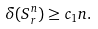Convert formula to latex. <formula><loc_0><loc_0><loc_500><loc_500>\delta ( S _ { r } ^ { n } ) \geq c _ { 1 } n .</formula> 